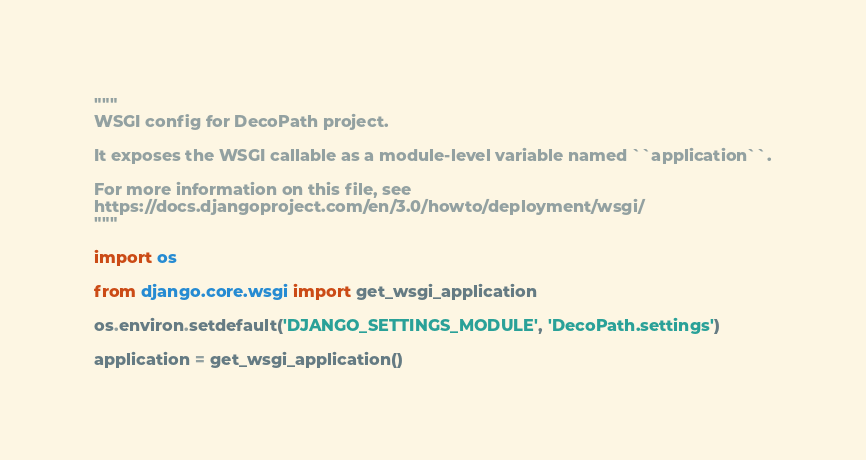<code> <loc_0><loc_0><loc_500><loc_500><_Python_>"""
WSGI config for DecoPath project.

It exposes the WSGI callable as a module-level variable named ``application``.

For more information on this file, see
https://docs.djangoproject.com/en/3.0/howto/deployment/wsgi/
"""

import os

from django.core.wsgi import get_wsgi_application

os.environ.setdefault('DJANGO_SETTINGS_MODULE', 'DecoPath.settings')

application = get_wsgi_application()
</code> 